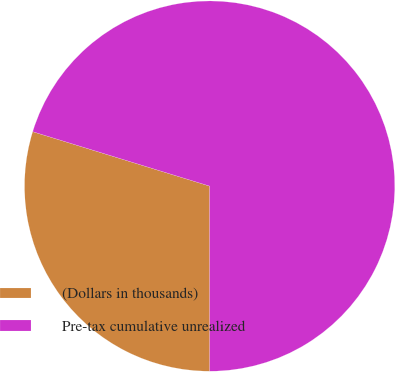Convert chart to OTSL. <chart><loc_0><loc_0><loc_500><loc_500><pie_chart><fcel>(Dollars in thousands)<fcel>Pre-tax cumulative unrealized<nl><fcel>29.76%<fcel>70.24%<nl></chart> 